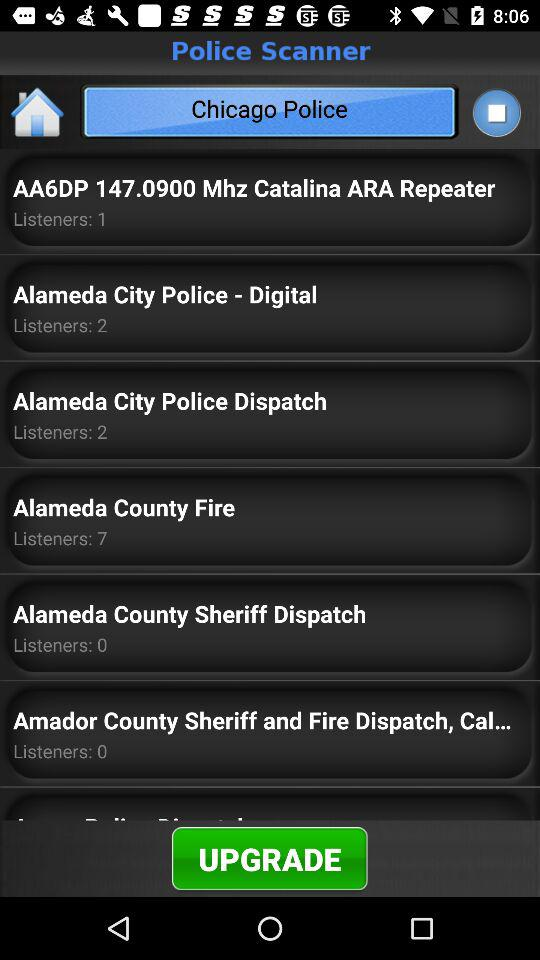What is the user's name?
When the provided information is insufficient, respond with <no answer>. <no answer> 